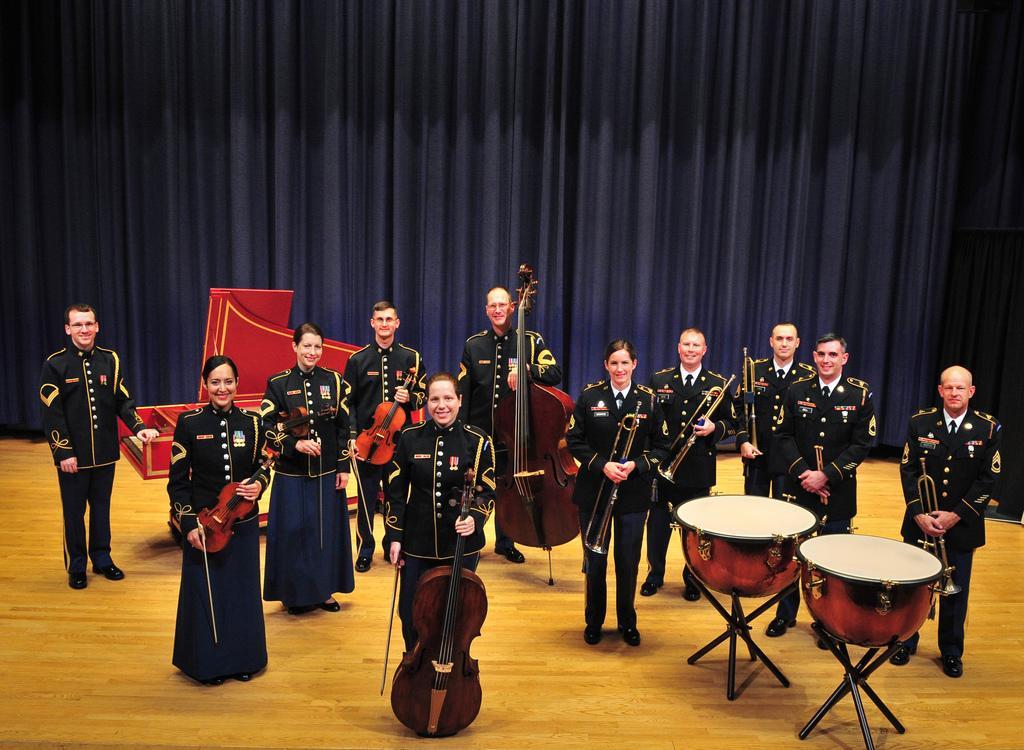How would you summarize this image in a sentence or two? There re some people standing on the stage with same uniform having a musical instruments in their hands. And there are two drums. There are women and men in this group. Behind them there is a curtain in the background. 